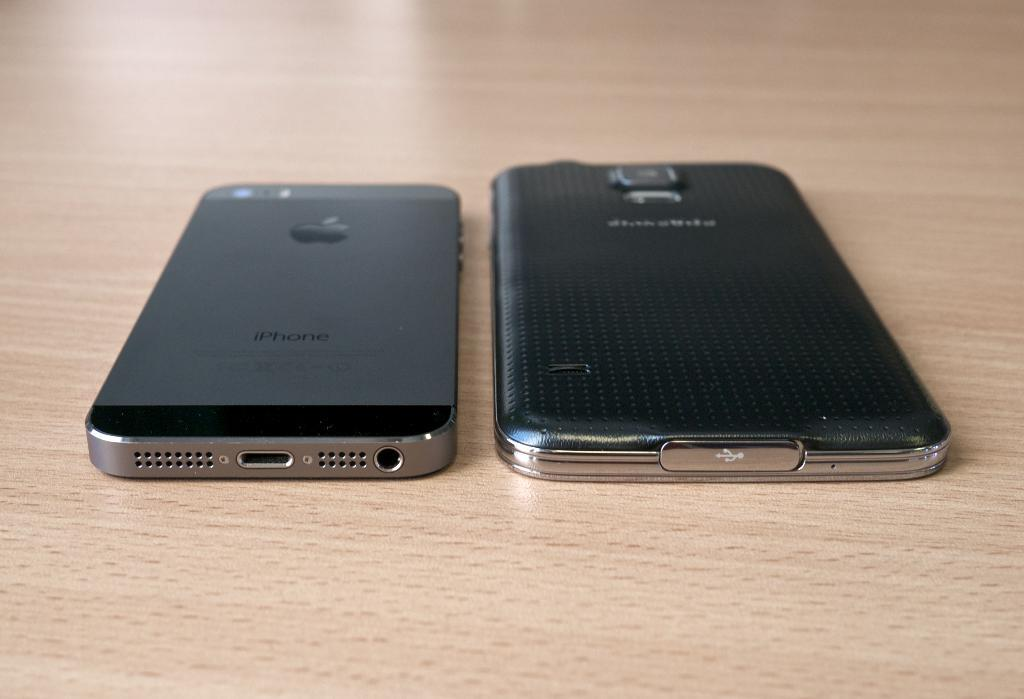Provide a one-sentence caption for the provided image. On a table there is an IPhone next to another different type of phone. 